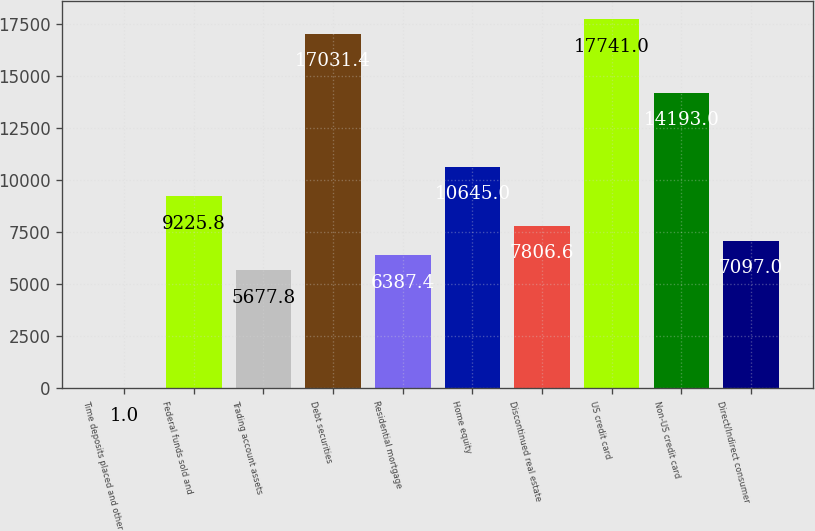Convert chart to OTSL. <chart><loc_0><loc_0><loc_500><loc_500><bar_chart><fcel>Time deposits placed and other<fcel>Federal funds sold and<fcel>Trading account assets<fcel>Debt securities<fcel>Residential mortgage<fcel>Home equity<fcel>Discontinued real estate<fcel>US credit card<fcel>Non-US credit card<fcel>Direct/Indirect consumer<nl><fcel>1<fcel>9225.8<fcel>5677.8<fcel>17031.4<fcel>6387.4<fcel>10645<fcel>7806.6<fcel>17741<fcel>14193<fcel>7097<nl></chart> 